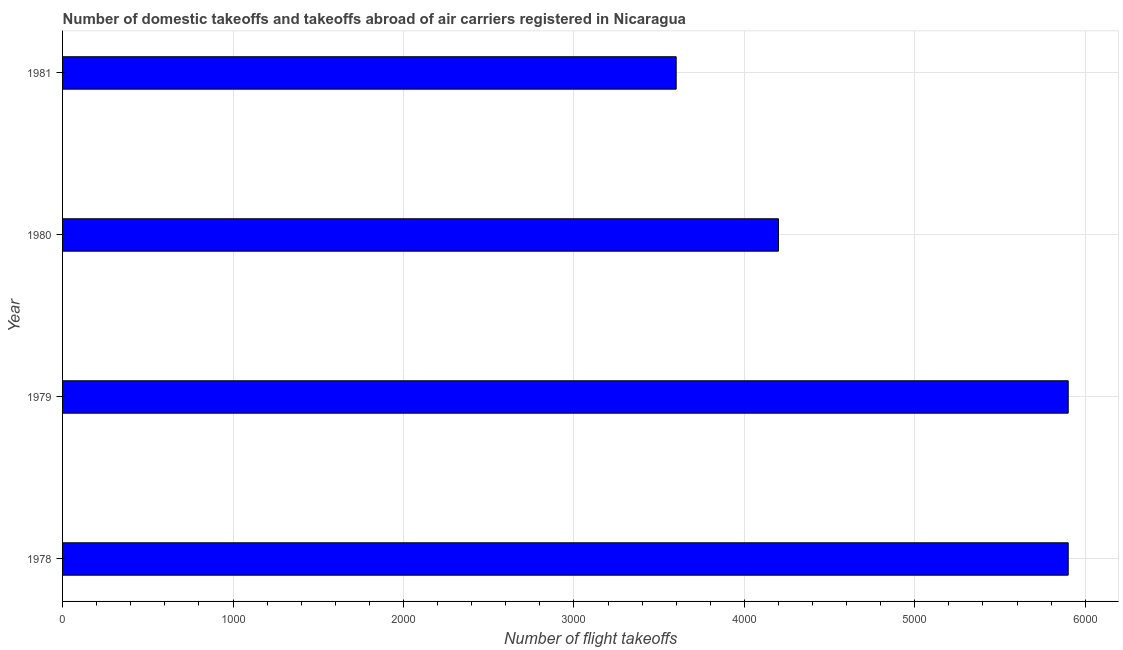Does the graph contain grids?
Keep it short and to the point. Yes. What is the title of the graph?
Make the answer very short. Number of domestic takeoffs and takeoffs abroad of air carriers registered in Nicaragua. What is the label or title of the X-axis?
Make the answer very short. Number of flight takeoffs. What is the label or title of the Y-axis?
Offer a very short reply. Year. What is the number of flight takeoffs in 1980?
Your answer should be compact. 4200. Across all years, what is the maximum number of flight takeoffs?
Keep it short and to the point. 5900. Across all years, what is the minimum number of flight takeoffs?
Ensure brevity in your answer.  3600. In which year was the number of flight takeoffs maximum?
Provide a succinct answer. 1978. In which year was the number of flight takeoffs minimum?
Provide a short and direct response. 1981. What is the sum of the number of flight takeoffs?
Ensure brevity in your answer.  1.96e+04. What is the difference between the number of flight takeoffs in 1979 and 1981?
Offer a terse response. 2300. What is the average number of flight takeoffs per year?
Provide a succinct answer. 4900. What is the median number of flight takeoffs?
Offer a very short reply. 5050. What is the ratio of the number of flight takeoffs in 1979 to that in 1981?
Give a very brief answer. 1.64. What is the difference between the highest and the second highest number of flight takeoffs?
Give a very brief answer. 0. Is the sum of the number of flight takeoffs in 1978 and 1979 greater than the maximum number of flight takeoffs across all years?
Your answer should be compact. Yes. What is the difference between the highest and the lowest number of flight takeoffs?
Provide a short and direct response. 2300. How many bars are there?
Offer a terse response. 4. How many years are there in the graph?
Your response must be concise. 4. What is the difference between two consecutive major ticks on the X-axis?
Your response must be concise. 1000. Are the values on the major ticks of X-axis written in scientific E-notation?
Offer a terse response. No. What is the Number of flight takeoffs of 1978?
Offer a very short reply. 5900. What is the Number of flight takeoffs of 1979?
Your answer should be very brief. 5900. What is the Number of flight takeoffs in 1980?
Your response must be concise. 4200. What is the Number of flight takeoffs in 1981?
Your response must be concise. 3600. What is the difference between the Number of flight takeoffs in 1978 and 1979?
Keep it short and to the point. 0. What is the difference between the Number of flight takeoffs in 1978 and 1980?
Make the answer very short. 1700. What is the difference between the Number of flight takeoffs in 1978 and 1981?
Keep it short and to the point. 2300. What is the difference between the Number of flight takeoffs in 1979 and 1980?
Your answer should be compact. 1700. What is the difference between the Number of flight takeoffs in 1979 and 1981?
Your answer should be compact. 2300. What is the difference between the Number of flight takeoffs in 1980 and 1981?
Provide a short and direct response. 600. What is the ratio of the Number of flight takeoffs in 1978 to that in 1979?
Your response must be concise. 1. What is the ratio of the Number of flight takeoffs in 1978 to that in 1980?
Keep it short and to the point. 1.41. What is the ratio of the Number of flight takeoffs in 1978 to that in 1981?
Give a very brief answer. 1.64. What is the ratio of the Number of flight takeoffs in 1979 to that in 1980?
Ensure brevity in your answer.  1.41. What is the ratio of the Number of flight takeoffs in 1979 to that in 1981?
Your answer should be very brief. 1.64. What is the ratio of the Number of flight takeoffs in 1980 to that in 1981?
Your answer should be compact. 1.17. 